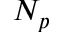Convert formula to latex. <formula><loc_0><loc_0><loc_500><loc_500>N _ { p }</formula> 